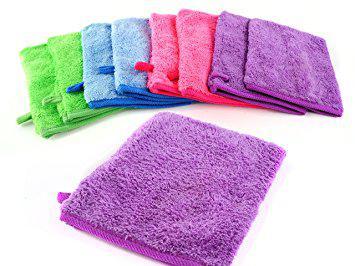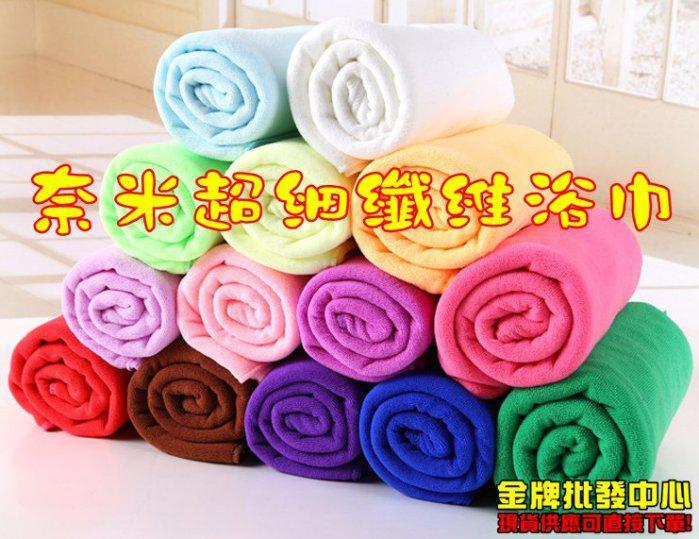The first image is the image on the left, the second image is the image on the right. Considering the images on both sides, is "Towels in one image, each of them a different color, are folded into neat stacked squares." valid? Answer yes or no. No. The first image is the image on the left, the second image is the image on the right. Evaluate the accuracy of this statement regarding the images: "The towels on the right side image are rolled up.". Is it true? Answer yes or no. Yes. 